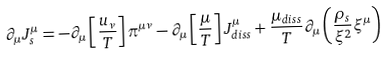<formula> <loc_0><loc_0><loc_500><loc_500>\partial _ { \mu } J ^ { \mu } _ { s } = - \partial _ { \mu } \left [ \frac { u _ { \nu } } { T } \right ] \pi ^ { \mu \nu } - \partial _ { \mu } \left [ \frac { \mu } { T } \right ] J _ { d i s s } ^ { \mu } + \frac { \mu _ { d i s s } } { T } \partial _ { \mu } \left ( \frac { \rho _ { s } } { \xi ^ { 2 } } \xi ^ { \mu } \right )</formula> 